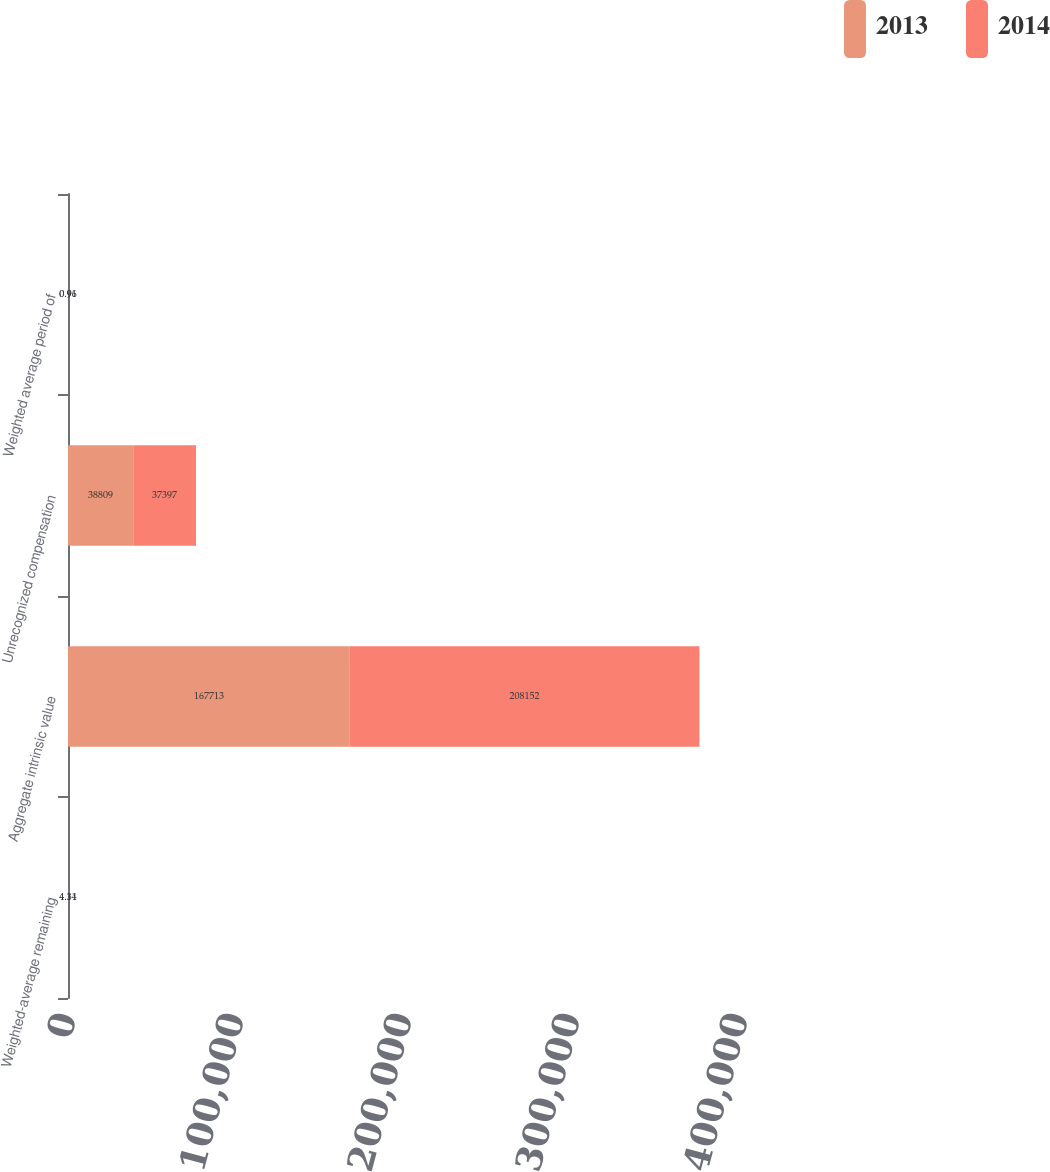Convert chart. <chart><loc_0><loc_0><loc_500><loc_500><stacked_bar_chart><ecel><fcel>Weighted-average remaining<fcel>Aggregate intrinsic value<fcel>Unrecognized compensation<fcel>Weighted average period of<nl><fcel>2013<fcel>4.34<fcel>167713<fcel>38809<fcel>0.91<nl><fcel>2014<fcel>4.11<fcel>208152<fcel>37397<fcel>0.96<nl></chart> 